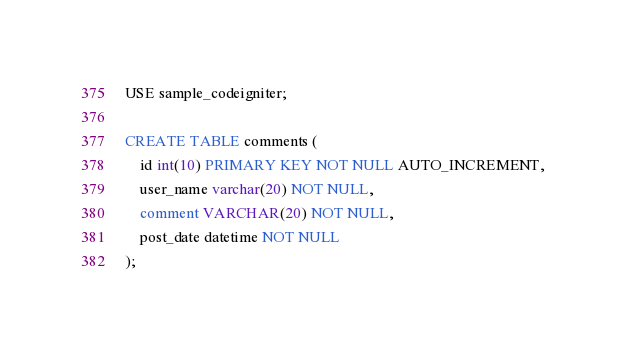<code> <loc_0><loc_0><loc_500><loc_500><_SQL_>USE sample_codeigniter;

CREATE TABLE comments (
    id int(10) PRIMARY KEY NOT NULL AUTO_INCREMENT,
    user_name varchar(20) NOT NULL,
    comment VARCHAR(20) NOT NULL,
    post_date datetime NOT NULL
);</code> 